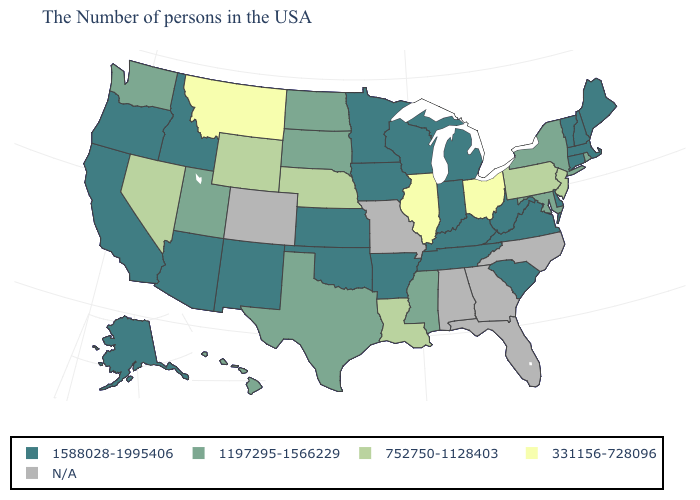How many symbols are there in the legend?
Keep it brief. 5. Which states have the highest value in the USA?
Keep it brief. Maine, Massachusetts, New Hampshire, Vermont, Connecticut, Delaware, Virginia, South Carolina, West Virginia, Michigan, Kentucky, Indiana, Tennessee, Wisconsin, Arkansas, Minnesota, Iowa, Kansas, Oklahoma, New Mexico, Arizona, Idaho, California, Oregon, Alaska. What is the value of Oklahoma?
Quick response, please. 1588028-1995406. What is the value of Maryland?
Short answer required. 1197295-1566229. What is the value of North Dakota?
Write a very short answer. 1197295-1566229. Among the states that border Wisconsin , which have the highest value?
Be succinct. Michigan, Minnesota, Iowa. What is the lowest value in the USA?
Short answer required. 331156-728096. What is the value of South Dakota?
Keep it brief. 1197295-1566229. What is the lowest value in the MidWest?
Give a very brief answer. 331156-728096. Does New Jersey have the lowest value in the Northeast?
Be succinct. Yes. Name the states that have a value in the range 331156-728096?
Give a very brief answer. Ohio, Illinois, Montana. What is the value of Kansas?
Give a very brief answer. 1588028-1995406. What is the value of Wisconsin?
Keep it brief. 1588028-1995406. 